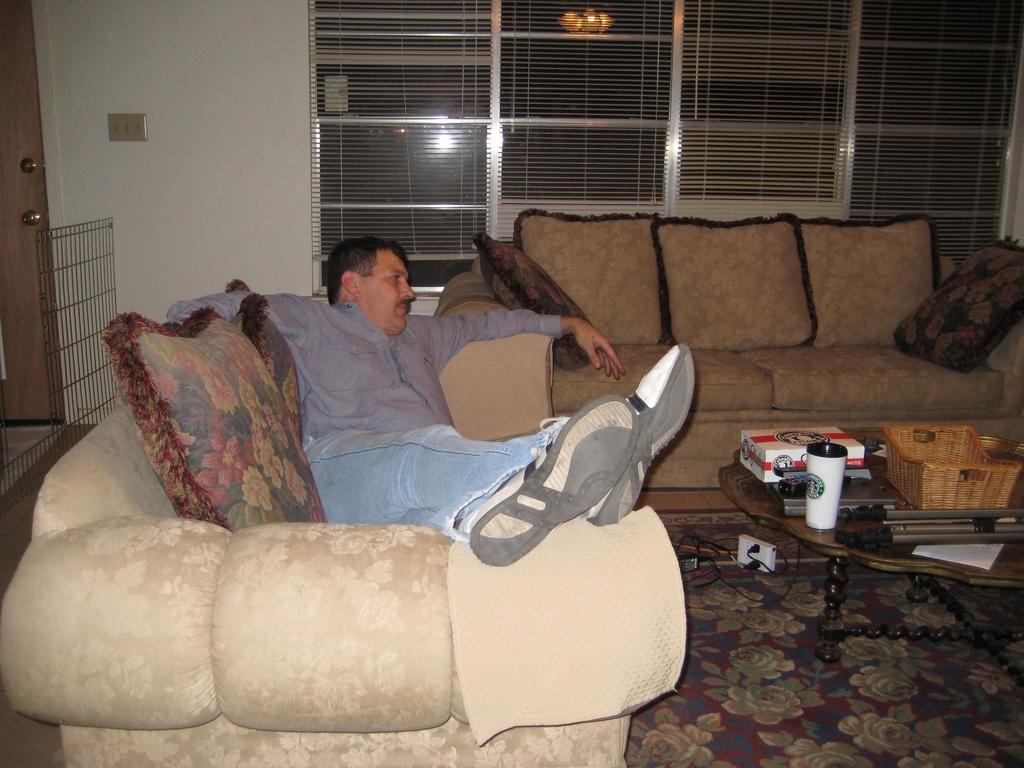Please provide a concise description of this image. There is a person who is lying on the couch and at the right side of the image there is an another couch and at the bottom right of the image there is a table on which there are different objects at the top of the image there is a window and at the left of the image there is a switch board and wooden door 